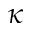<formula> <loc_0><loc_0><loc_500><loc_500>\kappa</formula> 